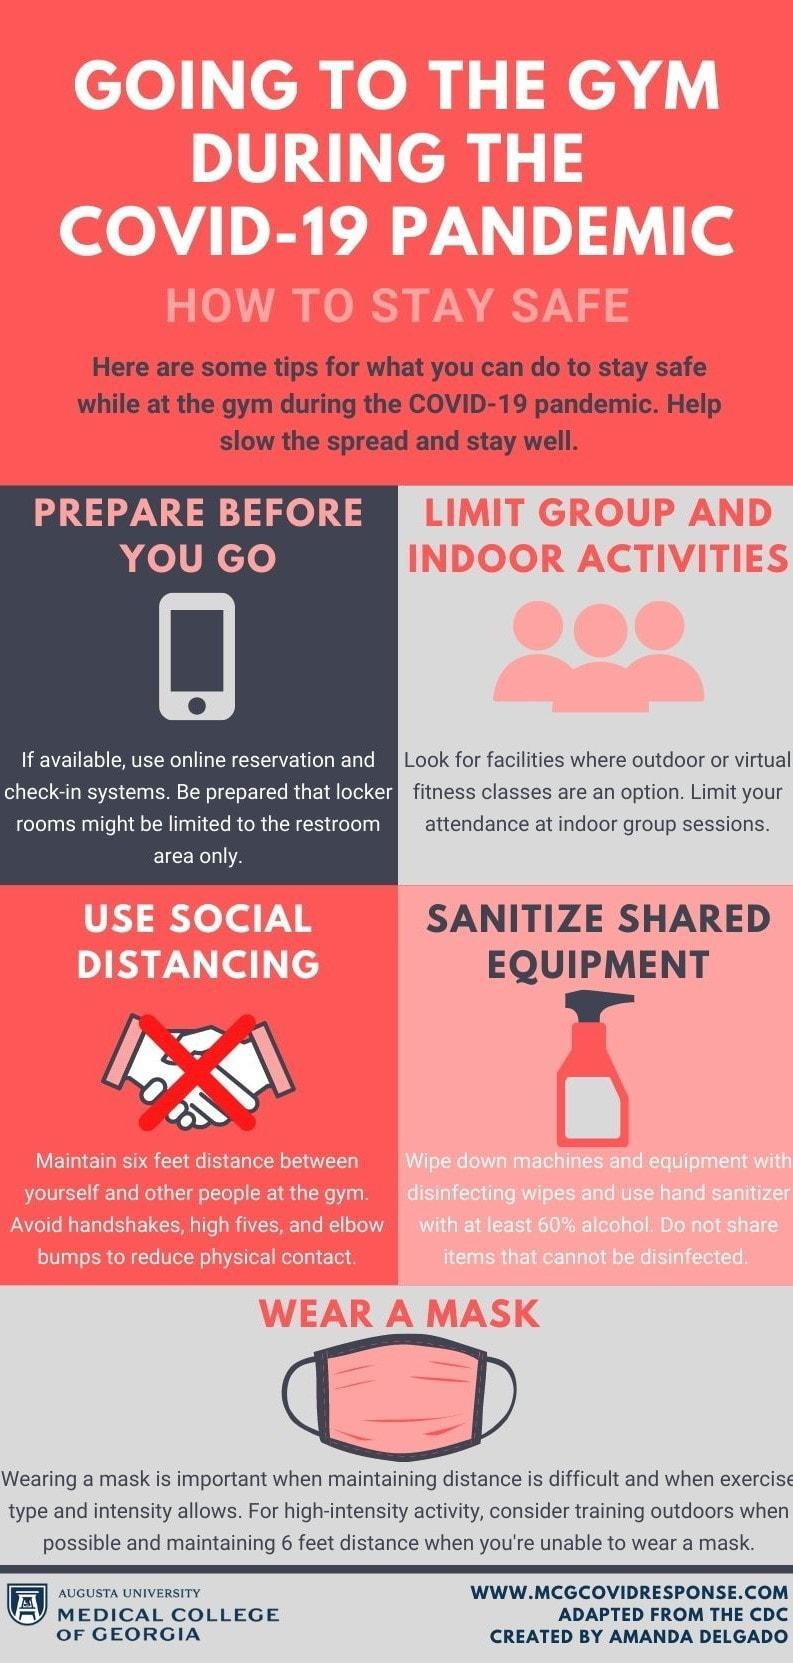How many masks are in this infographic?
Answer the question with a short phrase. 1 